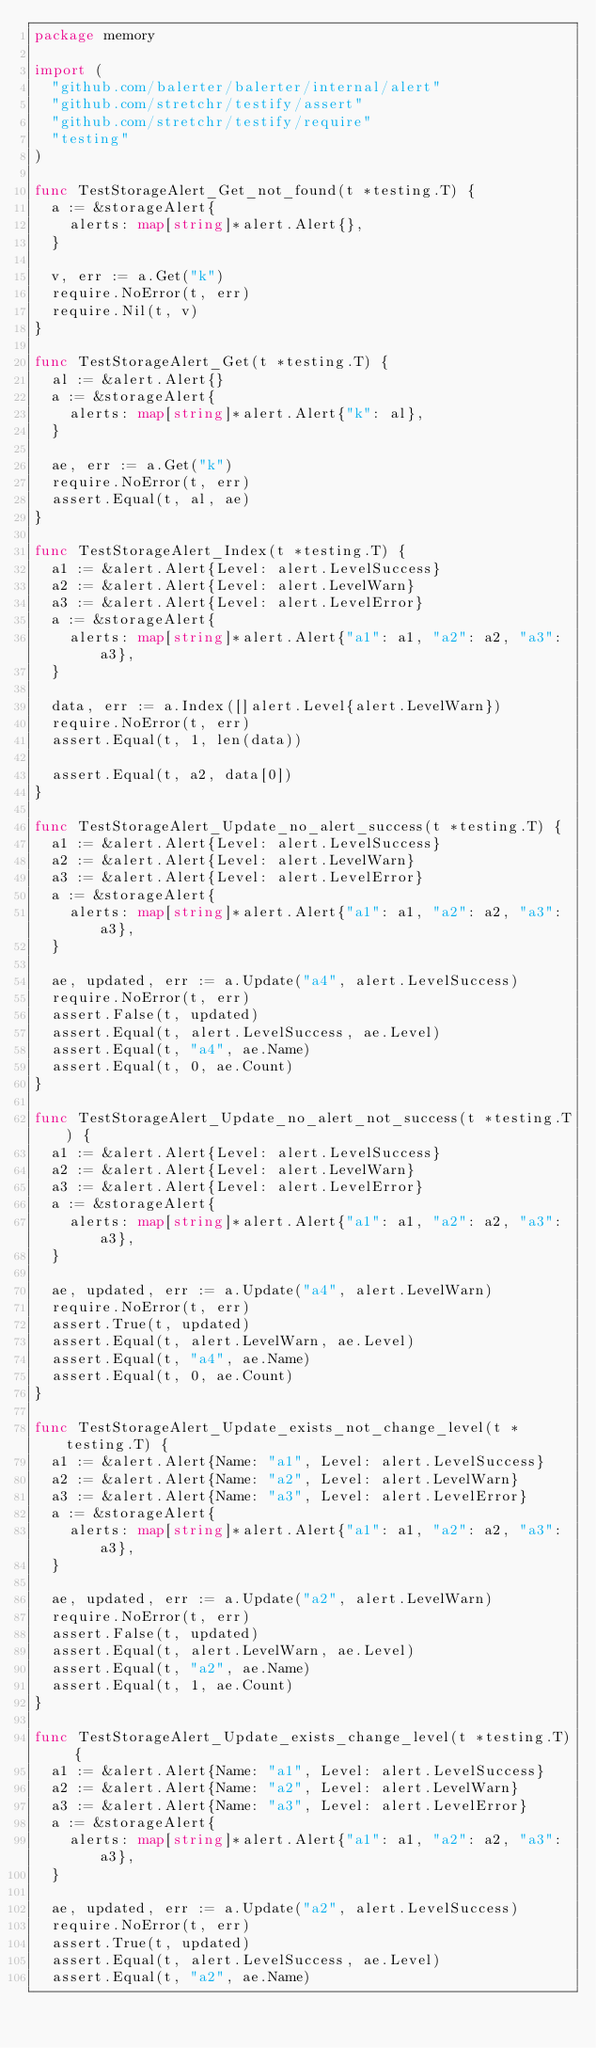<code> <loc_0><loc_0><loc_500><loc_500><_Go_>package memory

import (
	"github.com/balerter/balerter/internal/alert"
	"github.com/stretchr/testify/assert"
	"github.com/stretchr/testify/require"
	"testing"
)

func TestStorageAlert_Get_not_found(t *testing.T) {
	a := &storageAlert{
		alerts: map[string]*alert.Alert{},
	}

	v, err := a.Get("k")
	require.NoError(t, err)
	require.Nil(t, v)
}

func TestStorageAlert_Get(t *testing.T) {
	al := &alert.Alert{}
	a := &storageAlert{
		alerts: map[string]*alert.Alert{"k": al},
	}

	ae, err := a.Get("k")
	require.NoError(t, err)
	assert.Equal(t, al, ae)
}

func TestStorageAlert_Index(t *testing.T) {
	a1 := &alert.Alert{Level: alert.LevelSuccess}
	a2 := &alert.Alert{Level: alert.LevelWarn}
	a3 := &alert.Alert{Level: alert.LevelError}
	a := &storageAlert{
		alerts: map[string]*alert.Alert{"a1": a1, "a2": a2, "a3": a3},
	}

	data, err := a.Index([]alert.Level{alert.LevelWarn})
	require.NoError(t, err)
	assert.Equal(t, 1, len(data))

	assert.Equal(t, a2, data[0])
}

func TestStorageAlert_Update_no_alert_success(t *testing.T) {
	a1 := &alert.Alert{Level: alert.LevelSuccess}
	a2 := &alert.Alert{Level: alert.LevelWarn}
	a3 := &alert.Alert{Level: alert.LevelError}
	a := &storageAlert{
		alerts: map[string]*alert.Alert{"a1": a1, "a2": a2, "a3": a3},
	}

	ae, updated, err := a.Update("a4", alert.LevelSuccess)
	require.NoError(t, err)
	assert.False(t, updated)
	assert.Equal(t, alert.LevelSuccess, ae.Level)
	assert.Equal(t, "a4", ae.Name)
	assert.Equal(t, 0, ae.Count)
}

func TestStorageAlert_Update_no_alert_not_success(t *testing.T) {
	a1 := &alert.Alert{Level: alert.LevelSuccess}
	a2 := &alert.Alert{Level: alert.LevelWarn}
	a3 := &alert.Alert{Level: alert.LevelError}
	a := &storageAlert{
		alerts: map[string]*alert.Alert{"a1": a1, "a2": a2, "a3": a3},
	}

	ae, updated, err := a.Update("a4", alert.LevelWarn)
	require.NoError(t, err)
	assert.True(t, updated)
	assert.Equal(t, alert.LevelWarn, ae.Level)
	assert.Equal(t, "a4", ae.Name)
	assert.Equal(t, 0, ae.Count)
}

func TestStorageAlert_Update_exists_not_change_level(t *testing.T) {
	a1 := &alert.Alert{Name: "a1", Level: alert.LevelSuccess}
	a2 := &alert.Alert{Name: "a2", Level: alert.LevelWarn}
	a3 := &alert.Alert{Name: "a3", Level: alert.LevelError}
	a := &storageAlert{
		alerts: map[string]*alert.Alert{"a1": a1, "a2": a2, "a3": a3},
	}

	ae, updated, err := a.Update("a2", alert.LevelWarn)
	require.NoError(t, err)
	assert.False(t, updated)
	assert.Equal(t, alert.LevelWarn, ae.Level)
	assert.Equal(t, "a2", ae.Name)
	assert.Equal(t, 1, ae.Count)
}

func TestStorageAlert_Update_exists_change_level(t *testing.T) {
	a1 := &alert.Alert{Name: "a1", Level: alert.LevelSuccess}
	a2 := &alert.Alert{Name: "a2", Level: alert.LevelWarn}
	a3 := &alert.Alert{Name: "a3", Level: alert.LevelError}
	a := &storageAlert{
		alerts: map[string]*alert.Alert{"a1": a1, "a2": a2, "a3": a3},
	}

	ae, updated, err := a.Update("a2", alert.LevelSuccess)
	require.NoError(t, err)
	assert.True(t, updated)
	assert.Equal(t, alert.LevelSuccess, ae.Level)
	assert.Equal(t, "a2", ae.Name)</code> 